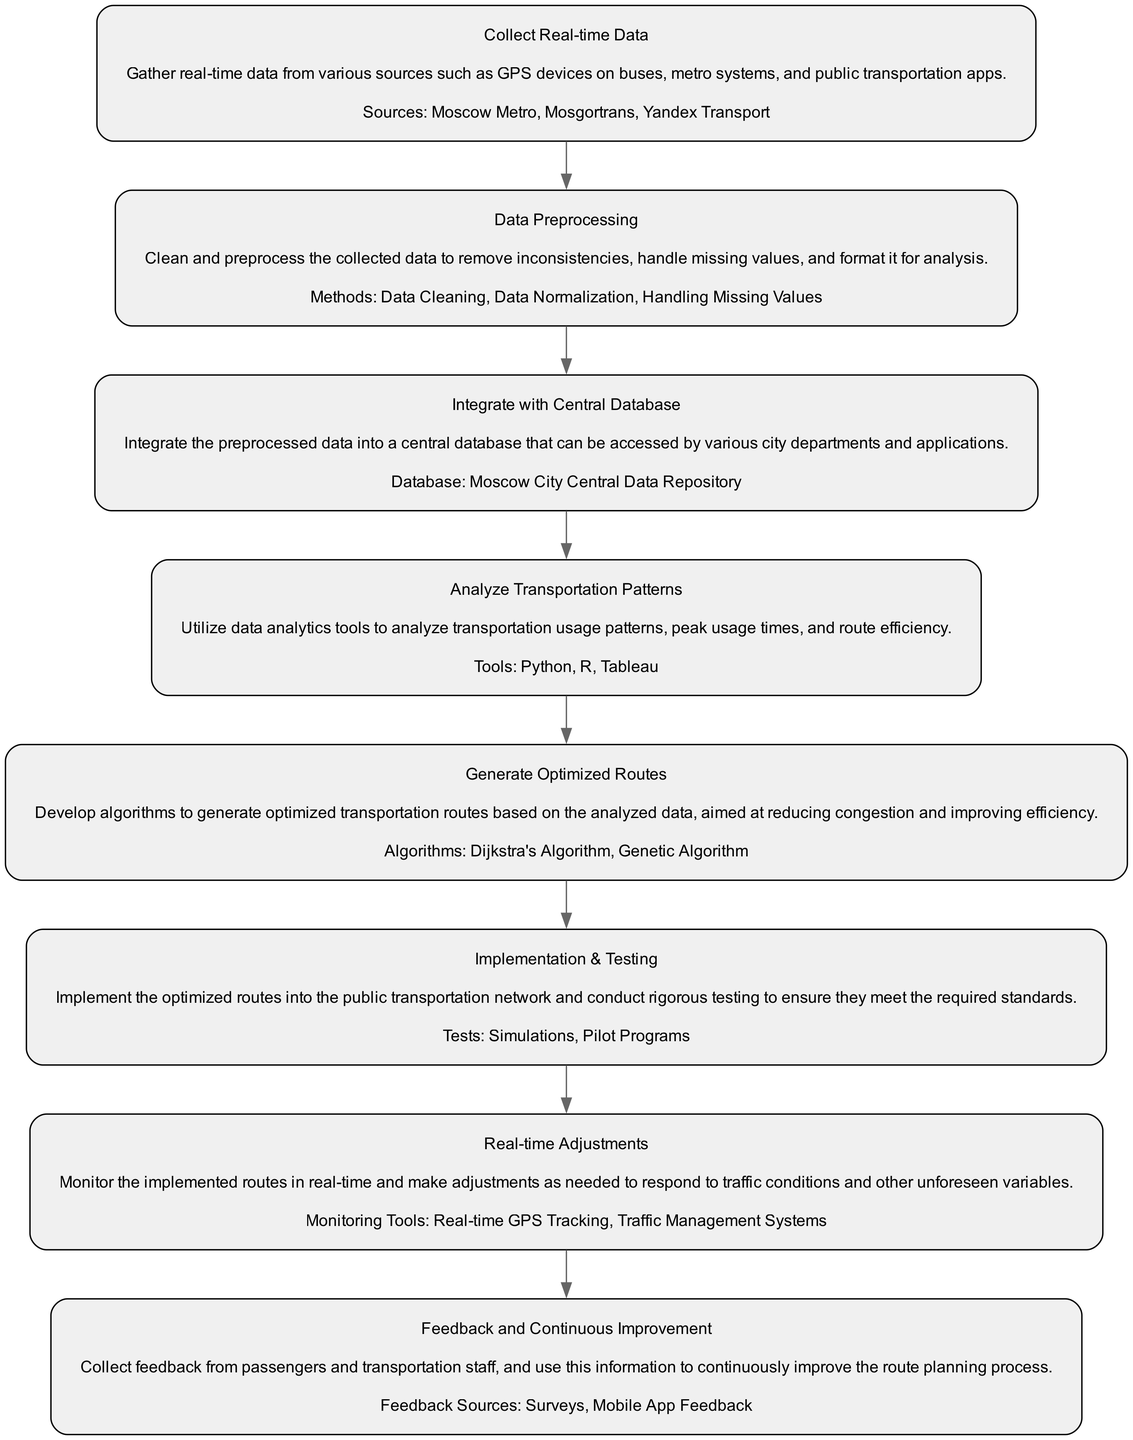What is the first step in the flowchart? The first step in the flowchart is "Collect Real-time Data," which involves gathering information from various transportation sources.
Answer: Collect Real-time Data How many elements are in the diagram? The diagram contains eight elements in total, each representing different stages of the public transportation route planning process.
Answer: Eight What are the sources mentioned in the "Collect Real-time Data" node? The sources include "Moscow Metro," "Mosgortrans," and "Yandex Transport," which are critical for gathering real-time data.
Answer: Moscow Metro, Mosgortrans, Yandex Transport What is the central database used for integration? The central database used is the "Moscow City Central Data Repository," where preprocessed data is stored and accessed by various departments.
Answer: Moscow City Central Data Repository Which tools are used in the "Analyze Transportation Patterns" step? The tools listed for analyzing transportation patterns are "Python," "R," and "Tableau," which facilitate data analysis and visualization.
Answer: Python, R, Tableau What follows after "Generate Optimized Routes" in the flowchart? The step that follows "Generate Optimized Routes" is "Implementation & Testing," where the optimized routes are put into practice and tested.
Answer: Implementation & Testing How is real-time monitoring conducted? Real-time monitoring is conducted using "Real-time GPS Tracking" and "Traffic Management Systems" to adapt to changing conditions.
Answer: Real-time GPS Tracking, Traffic Management Systems What type of feedback is collected for continuous improvement? Feedback sources include "Surveys" and "Mobile App Feedback," which help gather user experiences and suggestions for route planning improvements.
Answer: Surveys, Mobile App Feedback What algorithms are used to optimize routes? The algorithms employed to generate optimized routes are "Dijkstra's Algorithm" and "Genetic Algorithm," known for pathfinding and optimization tasks.
Answer: Dijkstra's Algorithm, Genetic Algorithm 